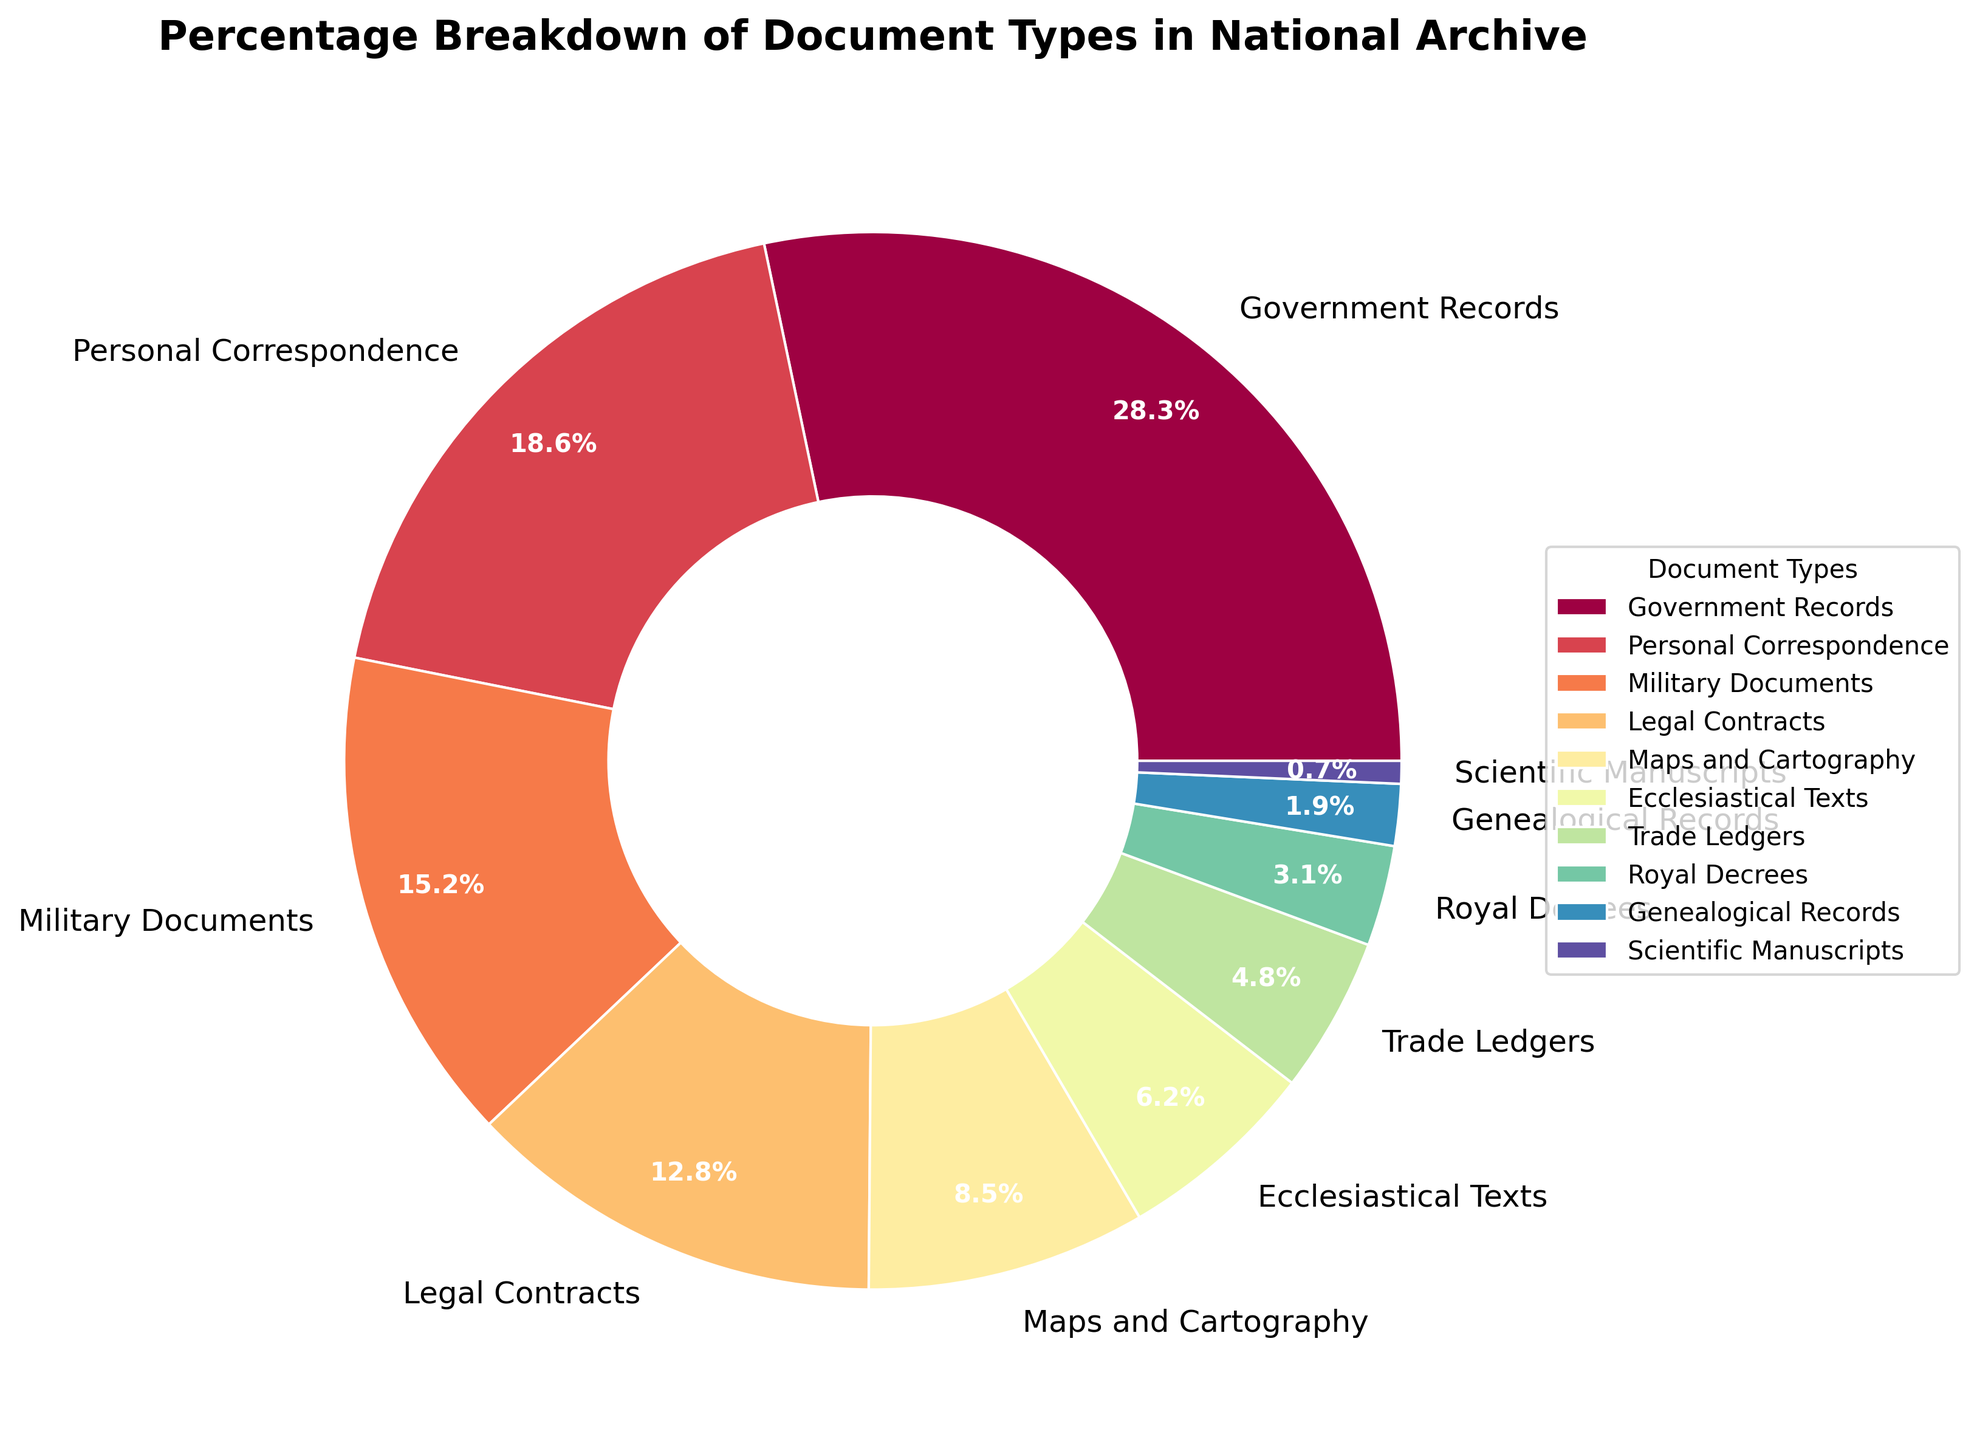Which document type has the highest percentage? The document type with the highest percentage can be identified by looking at the largest slice of the pie chart. In this case, Government Records have the highest percentage at 28.5%.
Answer: Government Records How much greater is the percentage of Personal Correspondence than Trade Ledgers? To find the difference, subtract the percentage of Trade Ledgers from Personal Correspondence: 18.7% - 4.8% = 13.9%.
Answer: 13.9% Which document types together make up more than 50% of the archive? Summing up the percentages from the largest downwards: Government Records (28.5%) + Personal Correspondence (18.7%) + Military Documents (15.3%) gives a total of 62.5%, which is more than 50%.
Answer: Government Records, Personal Correspondence, Military Documents Among the document types, which type has the smallest representation in the archive? The document type with the smallest percentage can be seen by identifying the smallest slice of the pie chart. Scientific Manuscripts have the smallest representation at 0.7%.
Answer: Scientific Manuscripts Are there more Legal Contracts or Ecclesiastical Texts? Compare the sizes of the slices for Legal Contracts and Ecclesiastical Texts. Legal Contracts, at 12.9%, have a greater percentage than Ecclesiastical Texts at 6.2%.
Answer: Legal Contracts If Maps and Cartography and Military Documents were combined into one category, what would be their total percentage? Sum the percentages of Maps and Cartography (8.6%) and Military Documents (15.3%): 8.6% + 15.3% = 23.9%.
Answer: 23.9% What is the combined percentage of Royal Decrees and Genealogical Records? Add the percentages of Royal Decrees (3.1%) and Genealogical Records (1.9%): 3.1% + 1.9% = 5.0%.
Answer: 5.0% Which document types have a percentage within the range of 10% to 20%? Observing the slices within this range, we find Personal Correspondence at 18.7% and Military Documents at 15.3%.
Answer: Personal Correspondence, Military Documents How does the percentage of Military Documents compare to Ecclesiastical Texts? Military Documents, at 15.3%, have a significantly higher percentage compared to Ecclesiastical Texts at 6.2%.
Answer: Military Documents have a higher percentage 